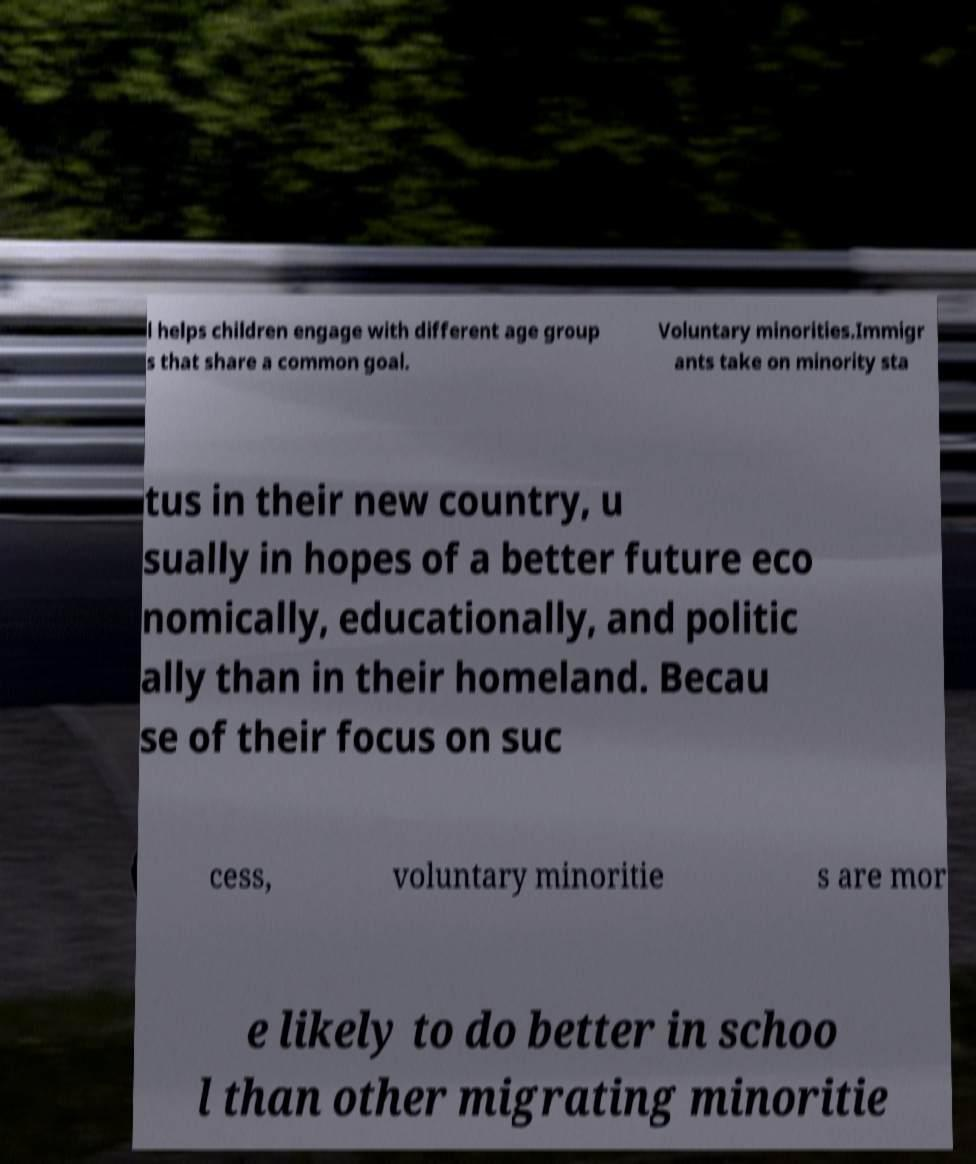Could you assist in decoding the text presented in this image and type it out clearly? l helps children engage with different age group s that share a common goal. Voluntary minorities.Immigr ants take on minority sta tus in their new country, u sually in hopes of a better future eco nomically, educationally, and politic ally than in their homeland. Becau se of their focus on suc cess, voluntary minoritie s are mor e likely to do better in schoo l than other migrating minoritie 